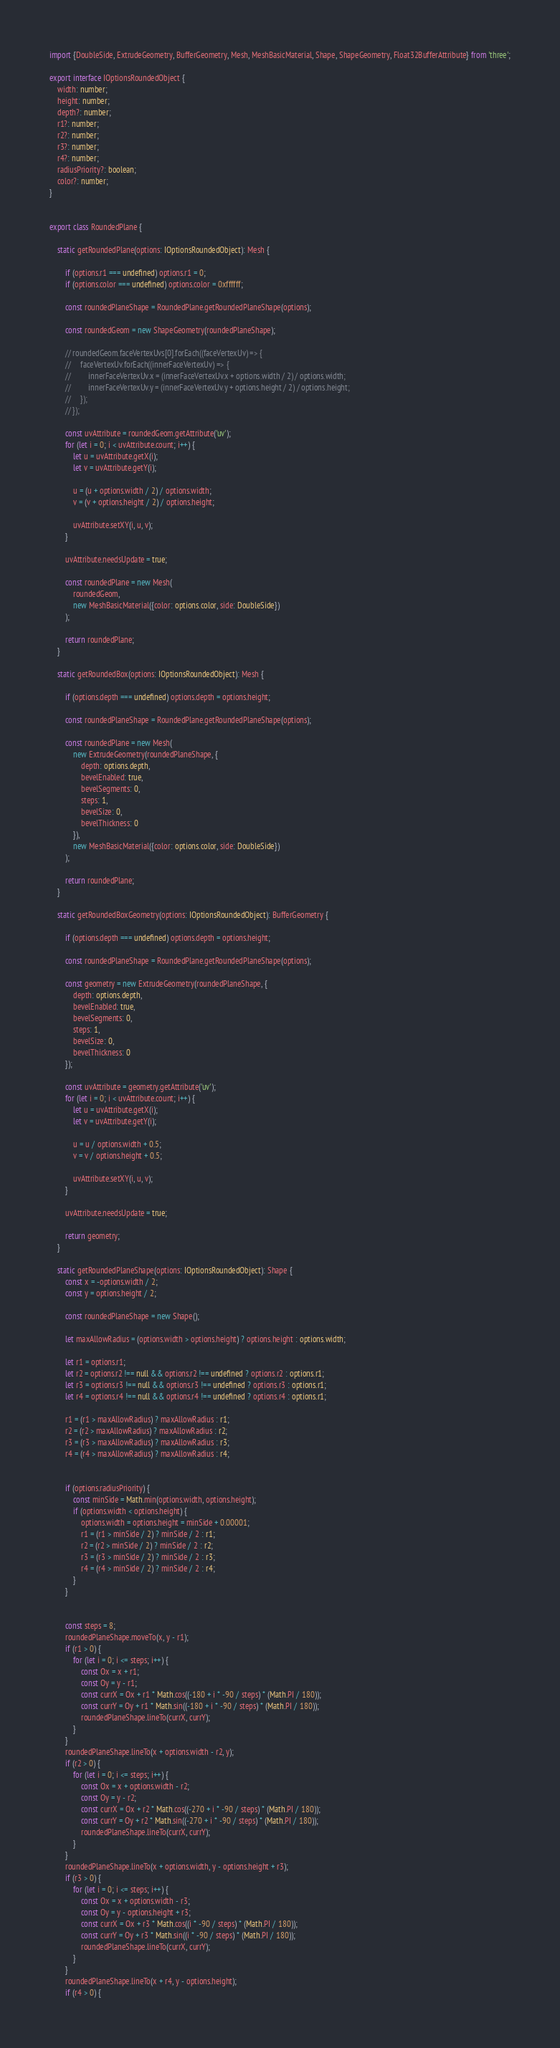Convert code to text. <code><loc_0><loc_0><loc_500><loc_500><_TypeScript_>import {DoubleSide, ExtrudeGeometry, BufferGeometry, Mesh, MeshBasicMaterial, Shape, ShapeGeometry, Float32BufferAttribute} from 'three';

export interface IOptionsRoundedObject {
    width: number;
    height: number;
    depth?: number;
    r1?: number;
    r2?: number;
    r3?: number;
    r4?: number;
    radiusPriority?: boolean;
    color?: number;
}


export class RoundedPlane {

    static getRoundedPlane(options: IOptionsRoundedObject): Mesh {

        if (options.r1 === undefined) options.r1 = 0;
        if (options.color === undefined) options.color = 0xffffff;

        const roundedPlaneShape = RoundedPlane.getRoundedPlaneShape(options);

        const roundedGeom = new ShapeGeometry(roundedPlaneShape);

        // roundedGeom.faceVertexUvs[0].forEach((faceVertexUv) => {
        //     faceVertexUv.forEach((innerFaceVertexUv) => {
        //         innerFaceVertexUv.x = (innerFaceVertexUv.x + options.width / 2) / options.width;
        //         innerFaceVertexUv.y = (innerFaceVertexUv.y + options.height / 2) / options.height;
        //     });
        // });

        const uvAttribute = roundedGeom.getAttribute('uv');
        for (let i = 0; i < uvAttribute.count; i++) {
            let u = uvAttribute.getX(i);
            let v = uvAttribute.getY(i);

            u = (u + options.width / 2) / options.width;
            v = (v + options.height / 2) / options.height;

            uvAttribute.setXY(i, u, v);
        }

        uvAttribute.needsUpdate = true;

        const roundedPlane = new Mesh(
            roundedGeom,
            new MeshBasicMaterial({color: options.color, side: DoubleSide})
        );

        return roundedPlane;
    }

    static getRoundedBox(options: IOptionsRoundedObject): Mesh {

        if (options.depth === undefined) options.depth = options.height;

        const roundedPlaneShape = RoundedPlane.getRoundedPlaneShape(options);

        const roundedPlane = new Mesh(
            new ExtrudeGeometry(roundedPlaneShape, {
                depth: options.depth,
                bevelEnabled: true,
                bevelSegments: 0,
                steps: 1,
                bevelSize: 0,
                bevelThickness: 0
            }),
            new MeshBasicMaterial({color: options.color, side: DoubleSide})
        );

        return roundedPlane;
    }

    static getRoundedBoxGeometry(options: IOptionsRoundedObject): BufferGeometry {

        if (options.depth === undefined) options.depth = options.height;

        const roundedPlaneShape = RoundedPlane.getRoundedPlaneShape(options);

        const geometry = new ExtrudeGeometry(roundedPlaneShape, {
            depth: options.depth,
            bevelEnabled: true,
            bevelSegments: 0,
            steps: 1,
            bevelSize: 0,
            bevelThickness: 0
        });

        const uvAttribute = geometry.getAttribute('uv');
        for (let i = 0; i < uvAttribute.count; i++) {
            let u = uvAttribute.getX(i);
            let v = uvAttribute.getY(i);

            u = u / options.width + 0.5;
            v = v / options.height + 0.5;

            uvAttribute.setXY(i, u, v);
        }

        uvAttribute.needsUpdate = true;

        return geometry;
    }

    static getRoundedPlaneShape(options: IOptionsRoundedObject): Shape {
        const x = -options.width / 2;
        const y = options.height / 2;

        const roundedPlaneShape = new Shape();

        let maxAllowRadius = (options.width > options.height) ? options.height : options.width;

        let r1 = options.r1;
        let r2 = options.r2 !== null && options.r2 !== undefined ? options.r2 : options.r1;
        let r3 = options.r3 !== null && options.r3 !== undefined ? options.r3 : options.r1;
        let r4 = options.r4 !== null && options.r4 !== undefined ? options.r4 : options.r1;

        r1 = (r1 > maxAllowRadius) ? maxAllowRadius : r1;
        r2 = (r2 > maxAllowRadius) ? maxAllowRadius : r2;
        r3 = (r3 > maxAllowRadius) ? maxAllowRadius : r3;
        r4 = (r4 > maxAllowRadius) ? maxAllowRadius : r4;


        if (options.radiusPriority) {
            const minSide = Math.min(options.width, options.height);
            if (options.width < options.height) {
                options.width = options.height = minSide + 0.00001;
                r1 = (r1 > minSide / 2) ? minSide / 2 : r1;
                r2 = (r2 > minSide / 2) ? minSide / 2 : r2;
                r3 = (r3 > minSide / 2) ? minSide / 2 : r3;
                r4 = (r4 > minSide / 2) ? minSide / 2 : r4;
            }
        }


        const steps = 8;
        roundedPlaneShape.moveTo(x, y - r1);
        if (r1 > 0) {
            for (let i = 0; i <= steps; i++) {
                const Ox = x + r1;
                const Oy = y - r1;
                const currX = Ox + r1 * Math.cos((-180 + i * -90 / steps) * (Math.PI / 180));
                const currY = Oy + r1 * Math.sin((-180 + i * -90 / steps) * (Math.PI / 180));
                roundedPlaneShape.lineTo(currX, currY);
            }
        }
        roundedPlaneShape.lineTo(x + options.width - r2, y);
        if (r2 > 0) {
            for (let i = 0; i <= steps; i++) {
                const Ox = x + options.width - r2;
                const Oy = y - r2;
                const currX = Ox + r2 * Math.cos((-270 + i * -90 / steps) * (Math.PI / 180));
                const currY = Oy + r2 * Math.sin((-270 + i * -90 / steps) * (Math.PI / 180));
                roundedPlaneShape.lineTo(currX, currY);
            }
        }
        roundedPlaneShape.lineTo(x + options.width, y - options.height + r3);
        if (r3 > 0) {
            for (let i = 0; i <= steps; i++) {
                const Ox = x + options.width - r3;
                const Oy = y - options.height + r3;
                const currX = Ox + r3 * Math.cos((i * -90 / steps) * (Math.PI / 180));
                const currY = Oy + r3 * Math.sin((i * -90 / steps) * (Math.PI / 180));
                roundedPlaneShape.lineTo(currX, currY);
            }
        }
        roundedPlaneShape.lineTo(x + r4, y - options.height);
        if (r4 > 0) {</code> 